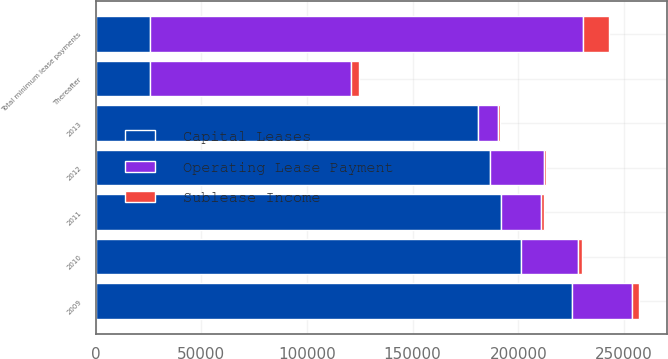Convert chart to OTSL. <chart><loc_0><loc_0><loc_500><loc_500><stacked_bar_chart><ecel><fcel>2009<fcel>2010<fcel>2011<fcel>2012<fcel>2013<fcel>Thereafter<fcel>Total minimum lease payments<nl><fcel>Capital Leases<fcel>225290<fcel>201315<fcel>191588<fcel>186600<fcel>181080<fcel>25489<fcel>25489<nl><fcel>Sublease Income<fcel>3341<fcel>1847<fcel>1223<fcel>1071<fcel>988<fcel>3539<fcel>12009<nl><fcel>Operating Lease Payment<fcel>28608<fcel>27146<fcel>19116<fcel>25489<fcel>9419<fcel>95445<fcel>205223<nl></chart> 